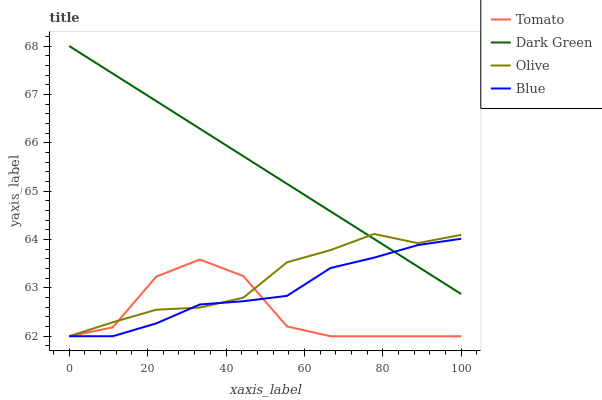Does Tomato have the minimum area under the curve?
Answer yes or no. Yes. Does Dark Green have the maximum area under the curve?
Answer yes or no. Yes. Does Olive have the minimum area under the curve?
Answer yes or no. No. Does Olive have the maximum area under the curve?
Answer yes or no. No. Is Dark Green the smoothest?
Answer yes or no. Yes. Is Tomato the roughest?
Answer yes or no. Yes. Is Olive the smoothest?
Answer yes or no. No. Is Olive the roughest?
Answer yes or no. No. Does Tomato have the lowest value?
Answer yes or no. Yes. Does Dark Green have the lowest value?
Answer yes or no. No. Does Dark Green have the highest value?
Answer yes or no. Yes. Does Olive have the highest value?
Answer yes or no. No. Is Tomato less than Dark Green?
Answer yes or no. Yes. Is Dark Green greater than Tomato?
Answer yes or no. Yes. Does Blue intersect Olive?
Answer yes or no. Yes. Is Blue less than Olive?
Answer yes or no. No. Is Blue greater than Olive?
Answer yes or no. No. Does Tomato intersect Dark Green?
Answer yes or no. No. 